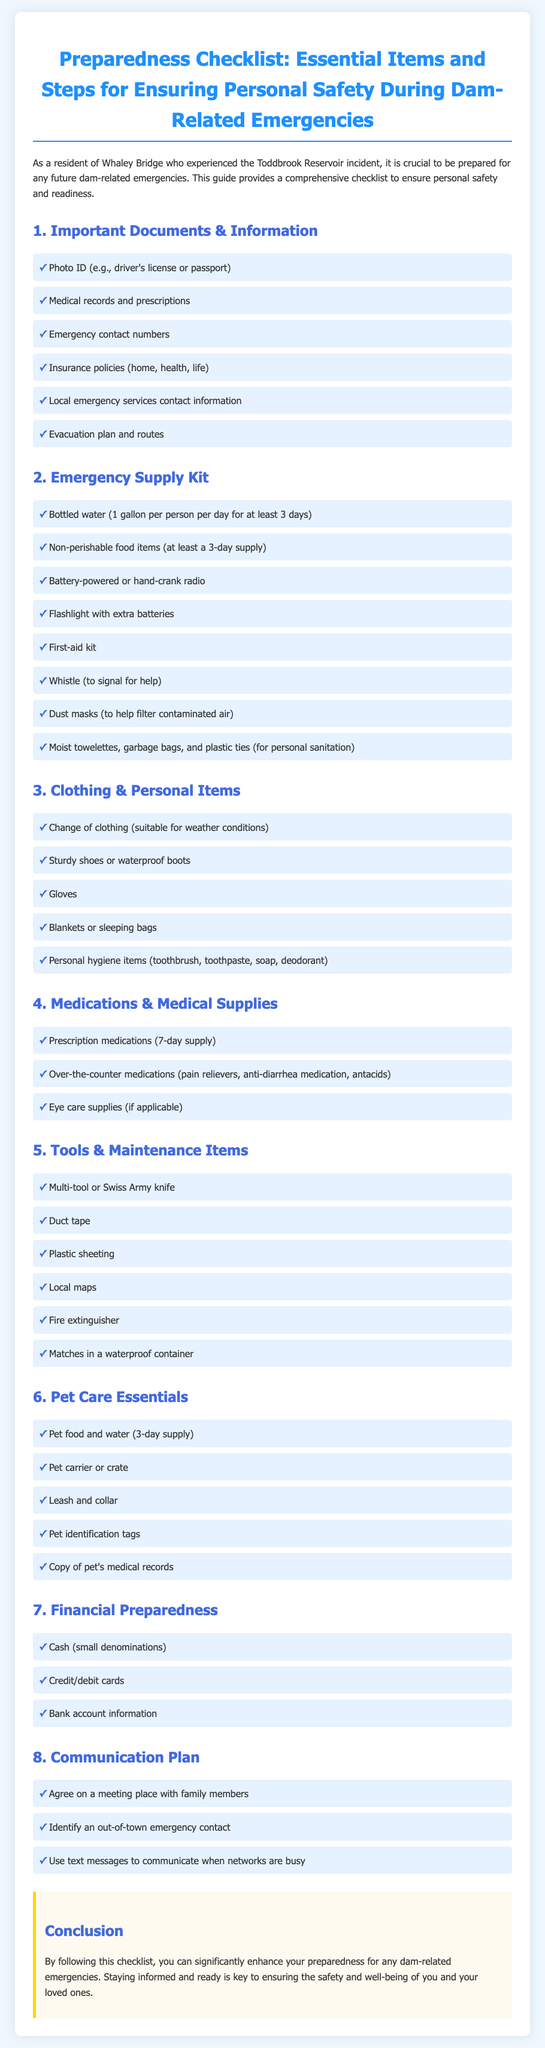what is the first item listed under Important Documents & Information? The first item under Important Documents & Information is "Photo ID (e.g., driver's license or passport)".
Answer: Photo ID how much bottled water should each person have for at least 3 days? The guideline states each person should have 1 gallon of bottled water per day for at least 3 days, which totals to 3 gallons.
Answer: 1 gallon what type of items are included in the Emergency Supply Kit? The Emergency Supply Kit contains essential items like bottled water, non-perishable food, and a flashlight.
Answer: Essential items how many prescription medications should be included in the Medications & Medical Supplies section? The checklist specifies a 7-day supply of prescription medications.
Answer: 7-day supply what should you do to communicate when networks are busy according to the Communication Plan? The document suggests using text messages to communicate when networks are busy.
Answer: Text messages what color are the headings in the checklist sections? The document indicates that the headings in the checklist sections are colored in a shade of blue, specifically #4169e1.
Answer: Blue what is the purpose of including pet care essentials? The purpose of including pet care essentials is to ensure the safety and well-being of pets during emergencies.
Answer: Ensure safety how many items are listed under Tools & Maintenance Items? There are a total of 6 items listed under Tools & Maintenance Items.
Answer: 6 items 